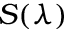<formula> <loc_0><loc_0><loc_500><loc_500>S ( \lambda )</formula> 